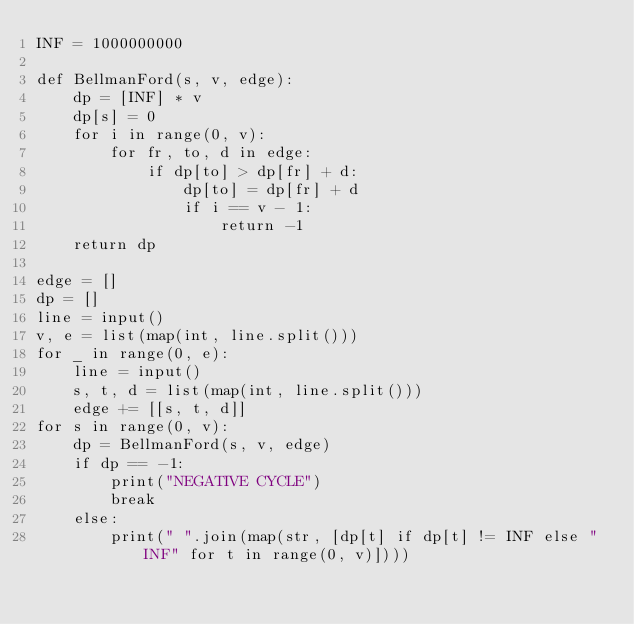Convert code to text. <code><loc_0><loc_0><loc_500><loc_500><_Python_>INF = 1000000000

def BellmanFord(s, v, edge):
    dp = [INF] * v
    dp[s] = 0
    for i in range(0, v):
        for fr, to, d in edge:
            if dp[to] > dp[fr] + d:
                dp[to] = dp[fr] + d
                if i == v - 1:
                    return -1
    return dp

edge = []
dp = []
line = input()
v, e = list(map(int, line.split()))
for _ in range(0, e):
    line = input()
    s, t, d = list(map(int, line.split()))
    edge += [[s, t, d]]
for s in range(0, v):
    dp = BellmanFord(s, v, edge)
    if dp == -1:
        print("NEGATIVE CYCLE")
        break
    else:
        print(" ".join(map(str, [dp[t] if dp[t] != INF else "INF" for t in range(0, v)])))
</code> 